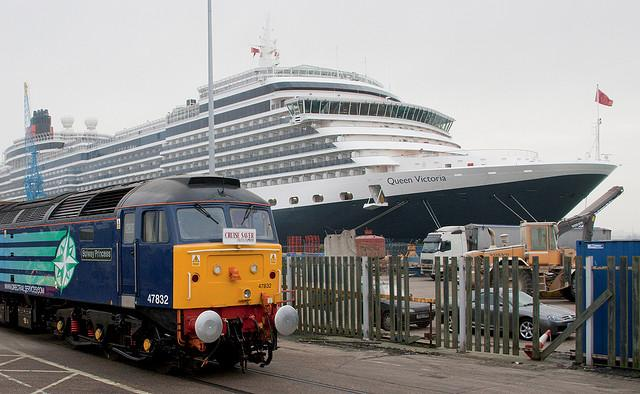The train is parked near what type of body of water? Please explain your reasoning. sea. There is a large ocean. 